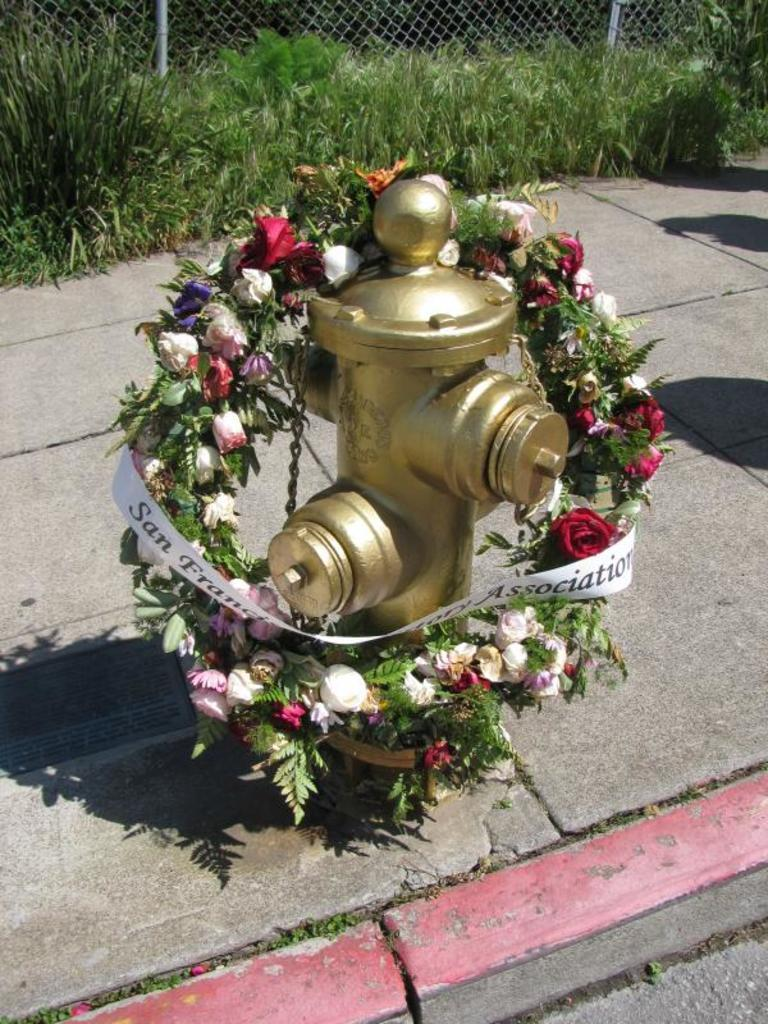What object is the main subject of the image? There is a fire hydrant in the image. What decoration is on the fire hydrant? The fire hydrant has a wreath. What can be seen behind the fire hydrant? There are plants and wire fencing behind the fire hydrant. What type of hair can be seen on the fire hydrant in the image? There is no hair present on the fire hydrant in the image. What is the weather like in the image? The provided facts do not mention the weather, so we cannot determine the weather from the image. 